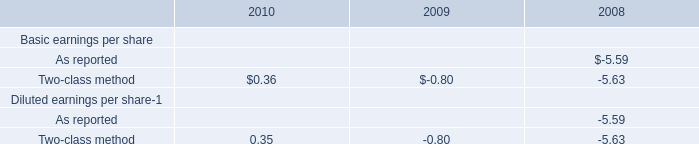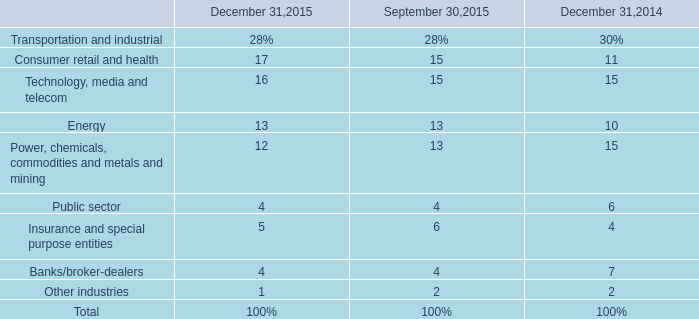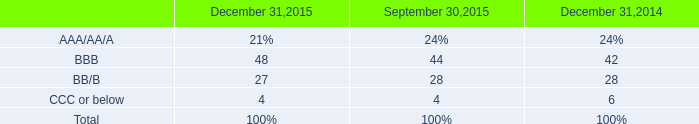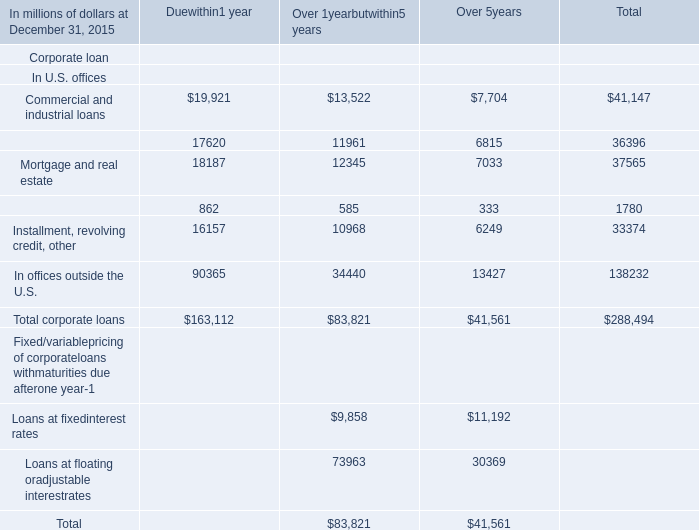What is the percentage of all Duewithin1 year that are positive to the total amount, in 2015 for Corporate loan In U.S. offices? 
Computations: ((((((19921 + 17620) + 18187) + 862) + 16157) + 90365) / 163112)
Answer: 1.0. 